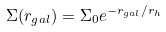<formula> <loc_0><loc_0><loc_500><loc_500>\Sigma ( r _ { g a l } ) = \Sigma _ { 0 } e ^ { - r _ { g a l } / r _ { h } }</formula> 